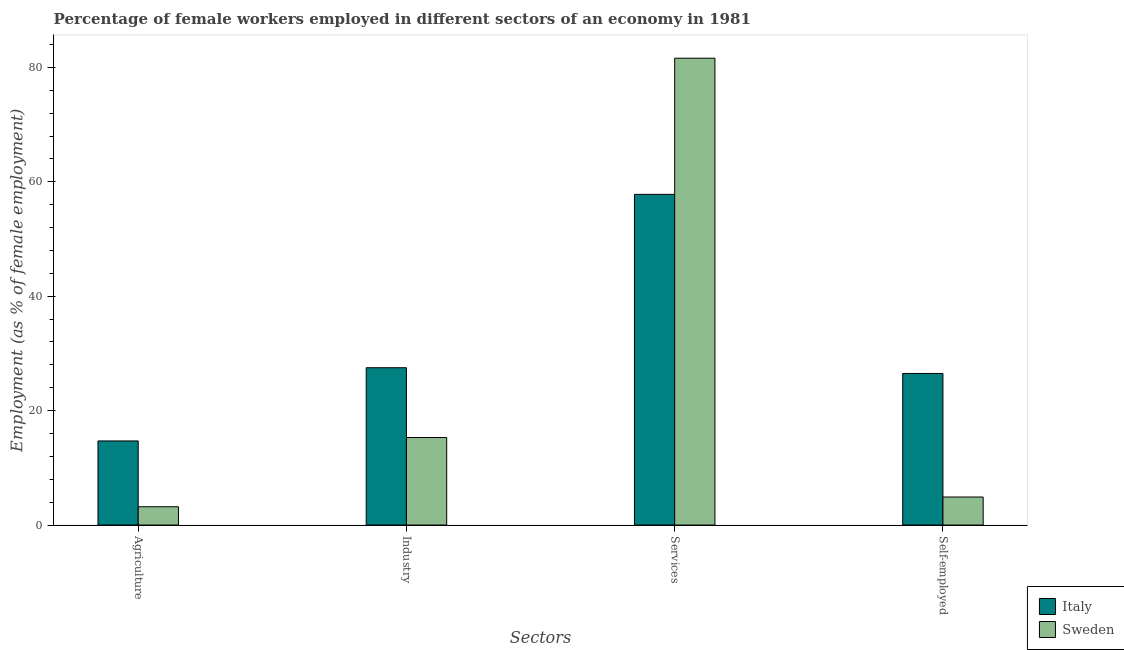Are the number of bars on each tick of the X-axis equal?
Give a very brief answer. Yes. What is the label of the 3rd group of bars from the left?
Your answer should be compact. Services. What is the percentage of female workers in agriculture in Italy?
Provide a short and direct response. 14.7. Across all countries, what is the maximum percentage of female workers in industry?
Ensure brevity in your answer.  27.5. Across all countries, what is the minimum percentage of female workers in industry?
Your answer should be compact. 15.3. What is the total percentage of female workers in agriculture in the graph?
Provide a succinct answer. 17.9. What is the difference between the percentage of self employed female workers in Italy and that in Sweden?
Ensure brevity in your answer.  21.6. What is the difference between the percentage of self employed female workers in Sweden and the percentage of female workers in services in Italy?
Your answer should be compact. -52.9. What is the average percentage of female workers in industry per country?
Give a very brief answer. 21.4. What is the difference between the percentage of female workers in industry and percentage of self employed female workers in Sweden?
Make the answer very short. 10.4. In how many countries, is the percentage of female workers in services greater than 64 %?
Your response must be concise. 1. What is the ratio of the percentage of self employed female workers in Sweden to that in Italy?
Provide a succinct answer. 0.18. Is the difference between the percentage of female workers in industry in Sweden and Italy greater than the difference between the percentage of self employed female workers in Sweden and Italy?
Make the answer very short. Yes. What is the difference between the highest and the second highest percentage of female workers in industry?
Offer a very short reply. 12.2. What is the difference between the highest and the lowest percentage of self employed female workers?
Ensure brevity in your answer.  21.6. In how many countries, is the percentage of female workers in services greater than the average percentage of female workers in services taken over all countries?
Offer a terse response. 1. Is it the case that in every country, the sum of the percentage of female workers in industry and percentage of female workers in agriculture is greater than the sum of percentage of female workers in services and percentage of self employed female workers?
Your answer should be very brief. No. Is it the case that in every country, the sum of the percentage of female workers in agriculture and percentage of female workers in industry is greater than the percentage of female workers in services?
Give a very brief answer. No. What is the difference between two consecutive major ticks on the Y-axis?
Your answer should be very brief. 20. Does the graph contain grids?
Your answer should be very brief. No. What is the title of the graph?
Keep it short and to the point. Percentage of female workers employed in different sectors of an economy in 1981. What is the label or title of the X-axis?
Make the answer very short. Sectors. What is the label or title of the Y-axis?
Your answer should be very brief. Employment (as % of female employment). What is the Employment (as % of female employment) in Italy in Agriculture?
Your answer should be compact. 14.7. What is the Employment (as % of female employment) of Sweden in Agriculture?
Offer a terse response. 3.2. What is the Employment (as % of female employment) of Sweden in Industry?
Your answer should be very brief. 15.3. What is the Employment (as % of female employment) of Italy in Services?
Provide a succinct answer. 57.8. What is the Employment (as % of female employment) in Sweden in Services?
Keep it short and to the point. 81.6. What is the Employment (as % of female employment) of Sweden in Self-employed?
Your response must be concise. 4.9. Across all Sectors, what is the maximum Employment (as % of female employment) of Italy?
Your answer should be very brief. 57.8. Across all Sectors, what is the maximum Employment (as % of female employment) in Sweden?
Your answer should be compact. 81.6. Across all Sectors, what is the minimum Employment (as % of female employment) in Italy?
Offer a very short reply. 14.7. Across all Sectors, what is the minimum Employment (as % of female employment) of Sweden?
Your response must be concise. 3.2. What is the total Employment (as % of female employment) in Italy in the graph?
Provide a short and direct response. 126.5. What is the total Employment (as % of female employment) of Sweden in the graph?
Offer a very short reply. 105. What is the difference between the Employment (as % of female employment) in Italy in Agriculture and that in Services?
Provide a succinct answer. -43.1. What is the difference between the Employment (as % of female employment) of Sweden in Agriculture and that in Services?
Give a very brief answer. -78.4. What is the difference between the Employment (as % of female employment) of Italy in Agriculture and that in Self-employed?
Provide a short and direct response. -11.8. What is the difference between the Employment (as % of female employment) of Sweden in Agriculture and that in Self-employed?
Your answer should be compact. -1.7. What is the difference between the Employment (as % of female employment) of Italy in Industry and that in Services?
Keep it short and to the point. -30.3. What is the difference between the Employment (as % of female employment) of Sweden in Industry and that in Services?
Provide a succinct answer. -66.3. What is the difference between the Employment (as % of female employment) of Italy in Industry and that in Self-employed?
Keep it short and to the point. 1. What is the difference between the Employment (as % of female employment) of Italy in Services and that in Self-employed?
Ensure brevity in your answer.  31.3. What is the difference between the Employment (as % of female employment) of Sweden in Services and that in Self-employed?
Make the answer very short. 76.7. What is the difference between the Employment (as % of female employment) of Italy in Agriculture and the Employment (as % of female employment) of Sweden in Services?
Provide a short and direct response. -66.9. What is the difference between the Employment (as % of female employment) in Italy in Agriculture and the Employment (as % of female employment) in Sweden in Self-employed?
Provide a succinct answer. 9.8. What is the difference between the Employment (as % of female employment) of Italy in Industry and the Employment (as % of female employment) of Sweden in Services?
Give a very brief answer. -54.1. What is the difference between the Employment (as % of female employment) in Italy in Industry and the Employment (as % of female employment) in Sweden in Self-employed?
Your answer should be compact. 22.6. What is the difference between the Employment (as % of female employment) in Italy in Services and the Employment (as % of female employment) in Sweden in Self-employed?
Give a very brief answer. 52.9. What is the average Employment (as % of female employment) in Italy per Sectors?
Your response must be concise. 31.62. What is the average Employment (as % of female employment) in Sweden per Sectors?
Provide a succinct answer. 26.25. What is the difference between the Employment (as % of female employment) of Italy and Employment (as % of female employment) of Sweden in Services?
Your response must be concise. -23.8. What is the difference between the Employment (as % of female employment) of Italy and Employment (as % of female employment) of Sweden in Self-employed?
Provide a succinct answer. 21.6. What is the ratio of the Employment (as % of female employment) of Italy in Agriculture to that in Industry?
Ensure brevity in your answer.  0.53. What is the ratio of the Employment (as % of female employment) of Sweden in Agriculture to that in Industry?
Provide a succinct answer. 0.21. What is the ratio of the Employment (as % of female employment) of Italy in Agriculture to that in Services?
Provide a short and direct response. 0.25. What is the ratio of the Employment (as % of female employment) in Sweden in Agriculture to that in Services?
Make the answer very short. 0.04. What is the ratio of the Employment (as % of female employment) in Italy in Agriculture to that in Self-employed?
Your response must be concise. 0.55. What is the ratio of the Employment (as % of female employment) of Sweden in Agriculture to that in Self-employed?
Your answer should be very brief. 0.65. What is the ratio of the Employment (as % of female employment) of Italy in Industry to that in Services?
Offer a terse response. 0.48. What is the ratio of the Employment (as % of female employment) in Sweden in Industry to that in Services?
Provide a succinct answer. 0.19. What is the ratio of the Employment (as % of female employment) of Italy in Industry to that in Self-employed?
Offer a very short reply. 1.04. What is the ratio of the Employment (as % of female employment) in Sweden in Industry to that in Self-employed?
Make the answer very short. 3.12. What is the ratio of the Employment (as % of female employment) of Italy in Services to that in Self-employed?
Provide a short and direct response. 2.18. What is the ratio of the Employment (as % of female employment) in Sweden in Services to that in Self-employed?
Your response must be concise. 16.65. What is the difference between the highest and the second highest Employment (as % of female employment) in Italy?
Your answer should be very brief. 30.3. What is the difference between the highest and the second highest Employment (as % of female employment) of Sweden?
Your response must be concise. 66.3. What is the difference between the highest and the lowest Employment (as % of female employment) in Italy?
Offer a very short reply. 43.1. What is the difference between the highest and the lowest Employment (as % of female employment) in Sweden?
Your answer should be very brief. 78.4. 